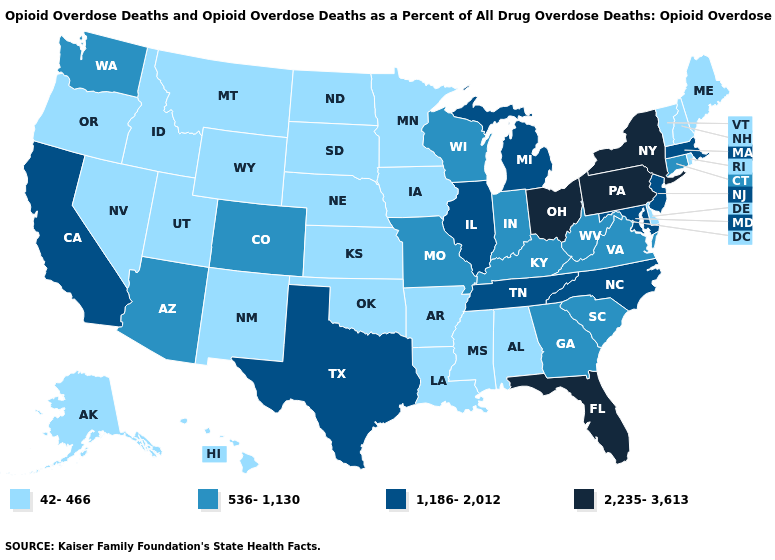Does Maine have a higher value than Delaware?
Quick response, please. No. Name the states that have a value in the range 536-1,130?
Give a very brief answer. Arizona, Colorado, Connecticut, Georgia, Indiana, Kentucky, Missouri, South Carolina, Virginia, Washington, West Virginia, Wisconsin. Does Illinois have a higher value than North Carolina?
Write a very short answer. No. Name the states that have a value in the range 536-1,130?
Answer briefly. Arizona, Colorado, Connecticut, Georgia, Indiana, Kentucky, Missouri, South Carolina, Virginia, Washington, West Virginia, Wisconsin. Name the states that have a value in the range 42-466?
Quick response, please. Alabama, Alaska, Arkansas, Delaware, Hawaii, Idaho, Iowa, Kansas, Louisiana, Maine, Minnesota, Mississippi, Montana, Nebraska, Nevada, New Hampshire, New Mexico, North Dakota, Oklahoma, Oregon, Rhode Island, South Dakota, Utah, Vermont, Wyoming. What is the value of Arizona?
Short answer required. 536-1,130. What is the value of South Dakota?
Quick response, please. 42-466. What is the value of North Carolina?
Answer briefly. 1,186-2,012. What is the value of New Jersey?
Answer briefly. 1,186-2,012. Does the map have missing data?
Answer briefly. No. Does Alaska have the same value as Vermont?
Keep it brief. Yes. Does Oklahoma have the lowest value in the USA?
Write a very short answer. Yes. Among the states that border North Carolina , which have the lowest value?
Short answer required. Georgia, South Carolina, Virginia. Does New York have the highest value in the Northeast?
Quick response, please. Yes. Which states have the lowest value in the Northeast?
Keep it brief. Maine, New Hampshire, Rhode Island, Vermont. 